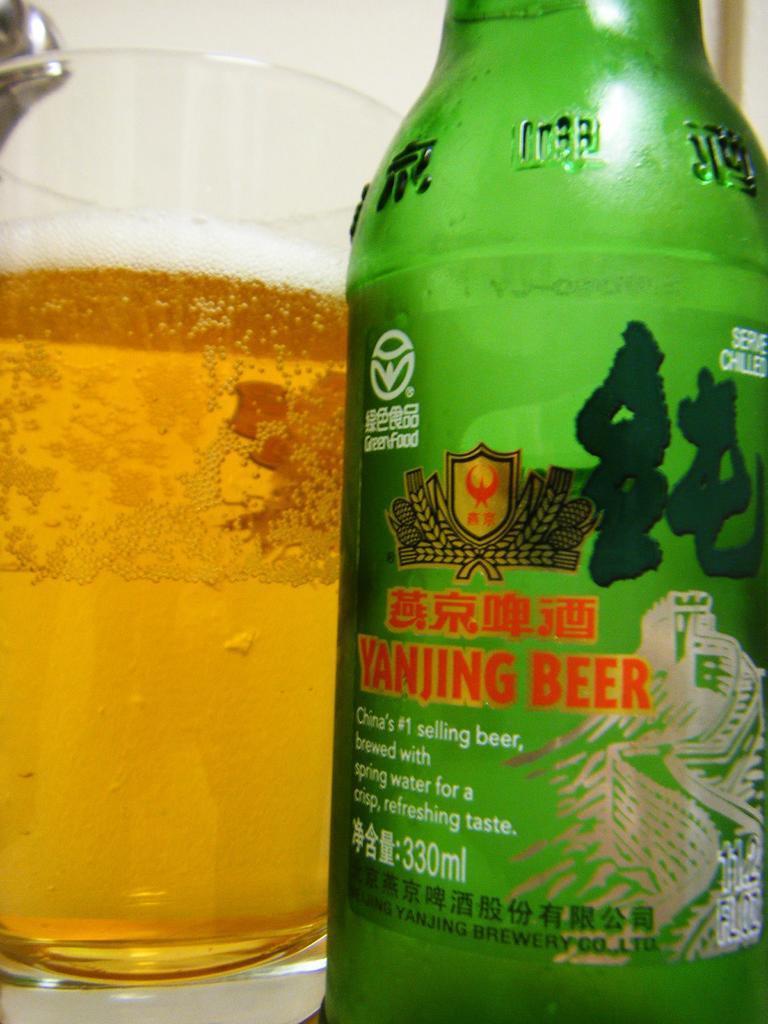What kind of beer is this?
Provide a succinct answer. Yanjing beer. How many ml is this bottle?
Give a very brief answer. 330. 